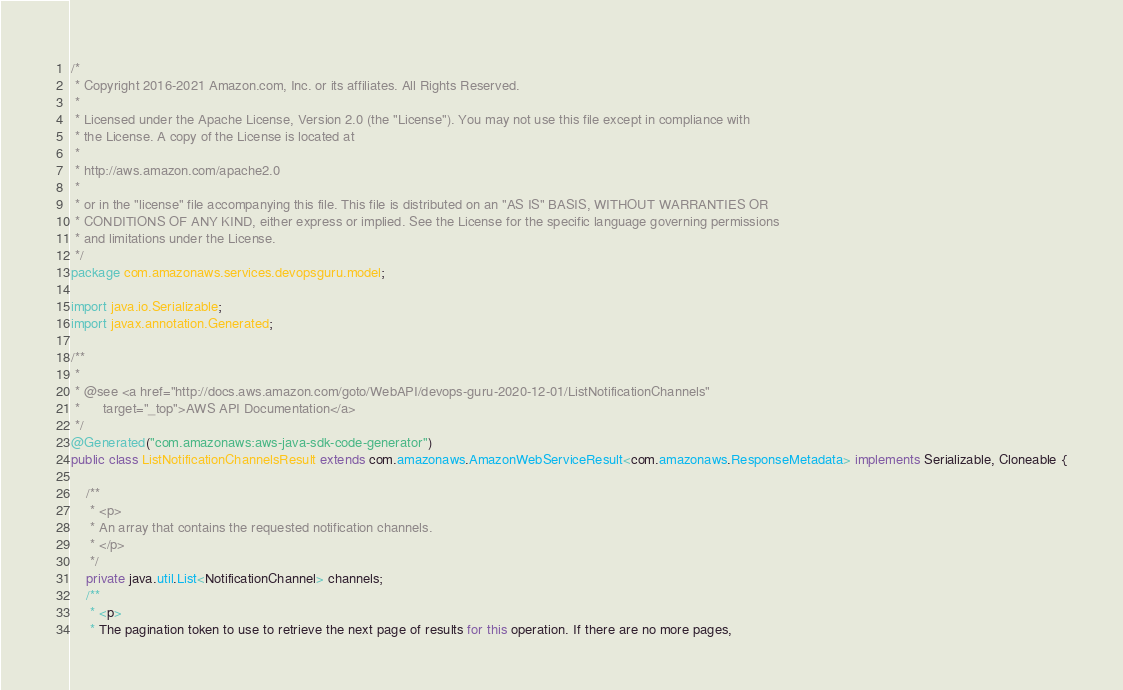Convert code to text. <code><loc_0><loc_0><loc_500><loc_500><_Java_>/*
 * Copyright 2016-2021 Amazon.com, Inc. or its affiliates. All Rights Reserved.
 * 
 * Licensed under the Apache License, Version 2.0 (the "License"). You may not use this file except in compliance with
 * the License. A copy of the License is located at
 * 
 * http://aws.amazon.com/apache2.0
 * 
 * or in the "license" file accompanying this file. This file is distributed on an "AS IS" BASIS, WITHOUT WARRANTIES OR
 * CONDITIONS OF ANY KIND, either express or implied. See the License for the specific language governing permissions
 * and limitations under the License.
 */
package com.amazonaws.services.devopsguru.model;

import java.io.Serializable;
import javax.annotation.Generated;

/**
 * 
 * @see <a href="http://docs.aws.amazon.com/goto/WebAPI/devops-guru-2020-12-01/ListNotificationChannels"
 *      target="_top">AWS API Documentation</a>
 */
@Generated("com.amazonaws:aws-java-sdk-code-generator")
public class ListNotificationChannelsResult extends com.amazonaws.AmazonWebServiceResult<com.amazonaws.ResponseMetadata> implements Serializable, Cloneable {

    /**
     * <p>
     * An array that contains the requested notification channels.
     * </p>
     */
    private java.util.List<NotificationChannel> channels;
    /**
     * <p>
     * The pagination token to use to retrieve the next page of results for this operation. If there are no more pages,</code> 